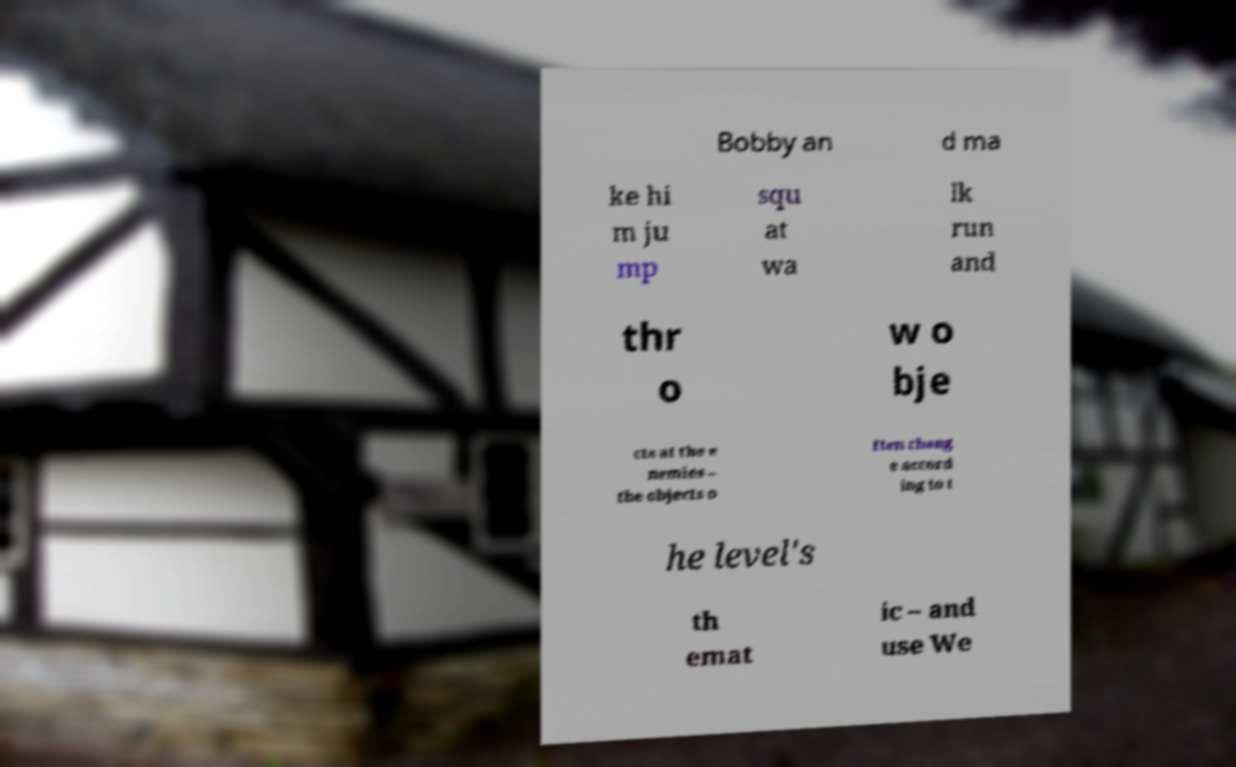For documentation purposes, I need the text within this image transcribed. Could you provide that? Bobby an d ma ke hi m ju mp squ at wa lk run and thr o w o bje cts at the e nemies – the objects o ften chang e accord ing to t he level's th emat ic – and use We 